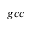Convert formula to latex. <formula><loc_0><loc_0><loc_500><loc_500>{ g c c }</formula> 